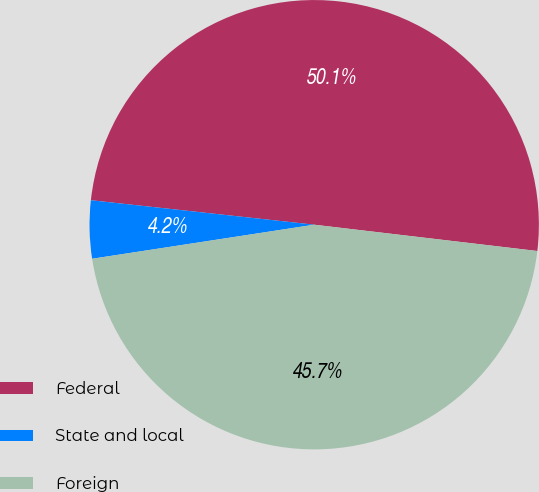<chart> <loc_0><loc_0><loc_500><loc_500><pie_chart><fcel>Federal<fcel>State and local<fcel>Foreign<nl><fcel>50.13%<fcel>4.16%<fcel>45.71%<nl></chart> 